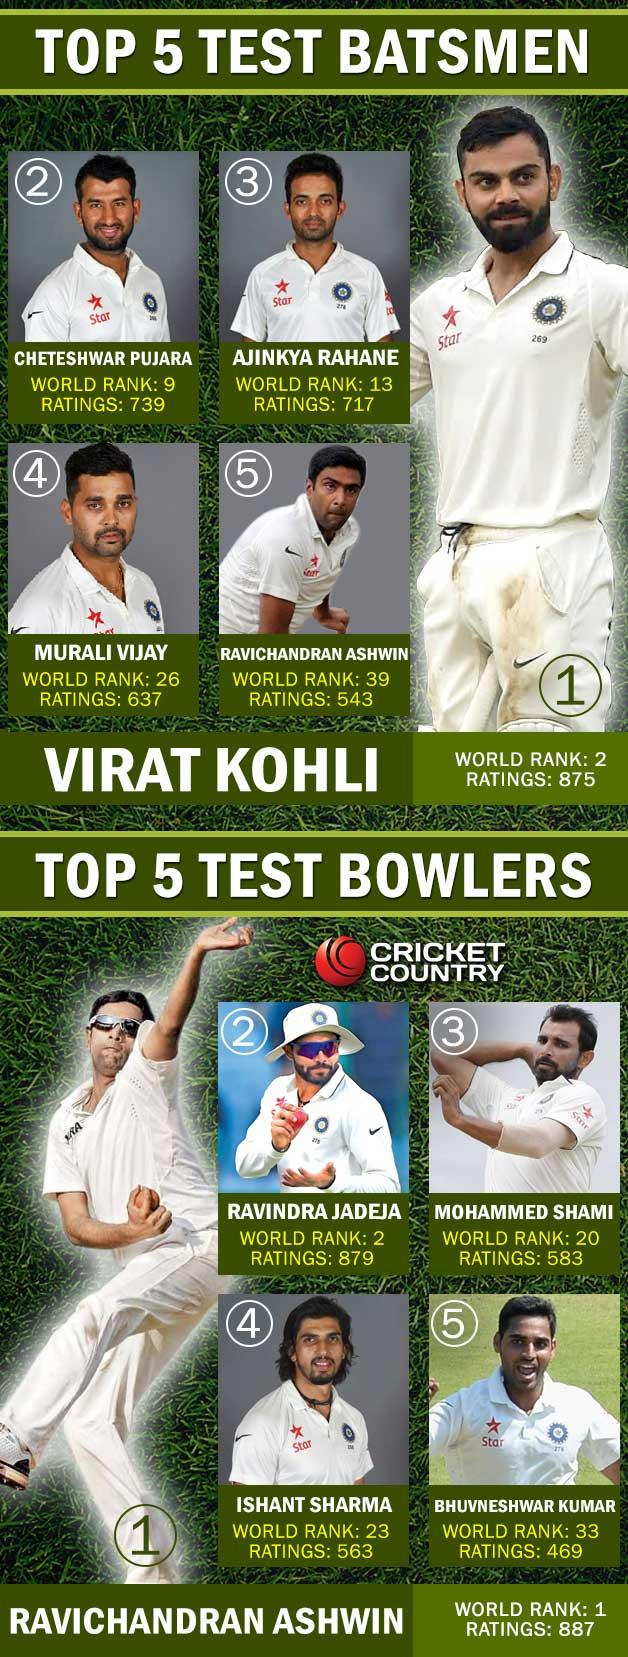List a handful of essential elements in this visual. Ravichandran Ashwin has a higher world rank in batting than Murali Vijay. Ravindra Jadeja has the highest world rank in bowling, as compared to Ishant Sharma. 